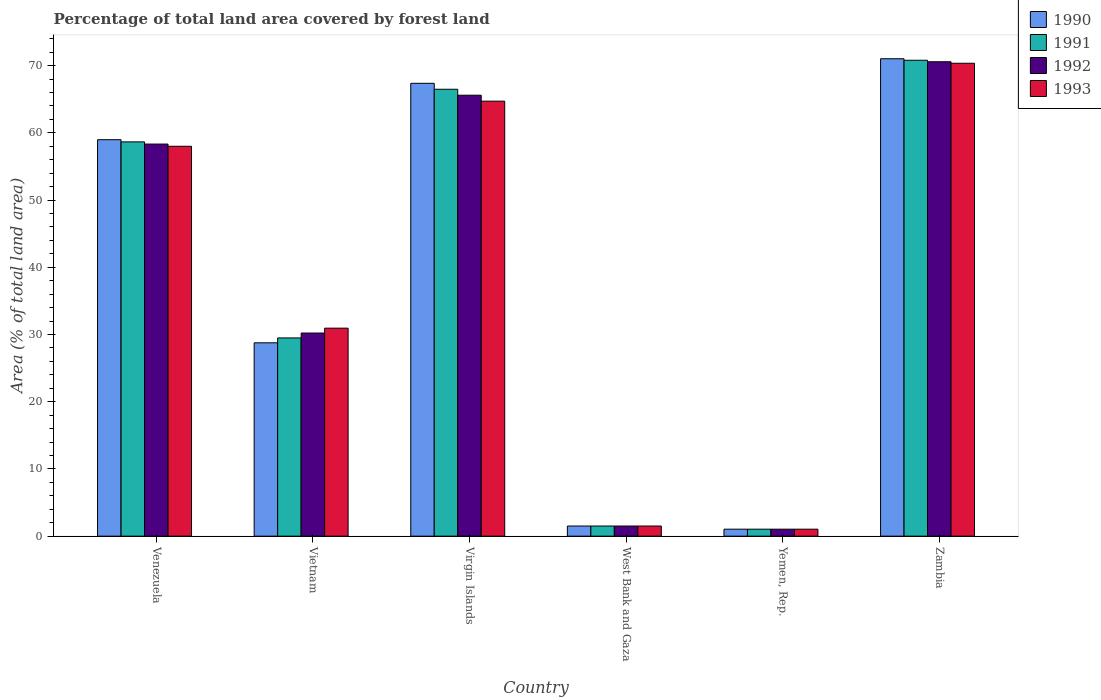How many groups of bars are there?
Your response must be concise. 6. What is the label of the 2nd group of bars from the left?
Offer a very short reply. Vietnam. In how many cases, is the number of bars for a given country not equal to the number of legend labels?
Your response must be concise. 0. What is the percentage of forest land in 1992 in West Bank and Gaza?
Your response must be concise. 1.51. Across all countries, what is the maximum percentage of forest land in 1993?
Provide a succinct answer. 70.35. Across all countries, what is the minimum percentage of forest land in 1991?
Give a very brief answer. 1.04. In which country was the percentage of forest land in 1990 maximum?
Provide a short and direct response. Zambia. In which country was the percentage of forest land in 1991 minimum?
Keep it short and to the point. Yemen, Rep. What is the total percentage of forest land in 1992 in the graph?
Your answer should be very brief. 227.28. What is the difference between the percentage of forest land in 1990 in Vietnam and that in West Bank and Gaza?
Offer a terse response. 27.26. What is the difference between the percentage of forest land in 1990 in Yemen, Rep. and the percentage of forest land in 1992 in Virgin Islands?
Your response must be concise. -64.56. What is the average percentage of forest land in 1992 per country?
Make the answer very short. 37.88. What is the difference between the percentage of forest land of/in 1990 and percentage of forest land of/in 1993 in Virgin Islands?
Your answer should be compact. 2.66. In how many countries, is the percentage of forest land in 1992 greater than 38 %?
Offer a very short reply. 3. What is the ratio of the percentage of forest land in 1991 in West Bank and Gaza to that in Zambia?
Keep it short and to the point. 0.02. Is the difference between the percentage of forest land in 1990 in Vietnam and Zambia greater than the difference between the percentage of forest land in 1993 in Vietnam and Zambia?
Ensure brevity in your answer.  No. What is the difference between the highest and the second highest percentage of forest land in 1992?
Keep it short and to the point. 7.27. What is the difference between the highest and the lowest percentage of forest land in 1992?
Make the answer very short. 69.54. Is the sum of the percentage of forest land in 1993 in Venezuela and West Bank and Gaza greater than the maximum percentage of forest land in 1990 across all countries?
Give a very brief answer. No. What does the 4th bar from the left in West Bank and Gaza represents?
Make the answer very short. 1993. Are all the bars in the graph horizontal?
Ensure brevity in your answer.  No. What is the difference between two consecutive major ticks on the Y-axis?
Give a very brief answer. 10. Does the graph contain any zero values?
Offer a terse response. No. Does the graph contain grids?
Your answer should be compact. No. Where does the legend appear in the graph?
Provide a short and direct response. Top right. How are the legend labels stacked?
Keep it short and to the point. Vertical. What is the title of the graph?
Your answer should be compact. Percentage of total land area covered by forest land. Does "2011" appear as one of the legend labels in the graph?
Ensure brevity in your answer.  No. What is the label or title of the Y-axis?
Your response must be concise. Area (% of total land area). What is the Area (% of total land area) in 1990 in Venezuela?
Provide a succinct answer. 58.98. What is the Area (% of total land area) in 1991 in Venezuela?
Provide a succinct answer. 58.66. What is the Area (% of total land area) in 1992 in Venezuela?
Provide a succinct answer. 58.33. What is the Area (% of total land area) of 1993 in Venezuela?
Provide a succinct answer. 58.01. What is the Area (% of total land area) in 1990 in Vietnam?
Provide a short and direct response. 28.77. What is the Area (% of total land area) of 1991 in Vietnam?
Your answer should be very brief. 29.49. What is the Area (% of total land area) in 1992 in Vietnam?
Provide a short and direct response. 30.22. What is the Area (% of total land area) in 1993 in Vietnam?
Keep it short and to the point. 30.94. What is the Area (% of total land area) of 1990 in Virgin Islands?
Offer a very short reply. 67.37. What is the Area (% of total land area) in 1991 in Virgin Islands?
Your answer should be compact. 66.49. What is the Area (% of total land area) of 1992 in Virgin Islands?
Make the answer very short. 65.6. What is the Area (% of total land area) of 1993 in Virgin Islands?
Offer a terse response. 64.71. What is the Area (% of total land area) of 1990 in West Bank and Gaza?
Keep it short and to the point. 1.51. What is the Area (% of total land area) in 1991 in West Bank and Gaza?
Offer a very short reply. 1.51. What is the Area (% of total land area) of 1992 in West Bank and Gaza?
Offer a terse response. 1.51. What is the Area (% of total land area) in 1993 in West Bank and Gaza?
Your response must be concise. 1.51. What is the Area (% of total land area) of 1990 in Yemen, Rep.?
Ensure brevity in your answer.  1.04. What is the Area (% of total land area) of 1991 in Yemen, Rep.?
Your answer should be compact. 1.04. What is the Area (% of total land area) of 1992 in Yemen, Rep.?
Provide a short and direct response. 1.04. What is the Area (% of total land area) of 1993 in Yemen, Rep.?
Provide a succinct answer. 1.04. What is the Area (% of total land area) of 1990 in Zambia?
Your answer should be very brief. 71.03. What is the Area (% of total land area) of 1991 in Zambia?
Your response must be concise. 70.8. What is the Area (% of total land area) in 1992 in Zambia?
Your answer should be compact. 70.58. What is the Area (% of total land area) of 1993 in Zambia?
Provide a short and direct response. 70.35. Across all countries, what is the maximum Area (% of total land area) of 1990?
Offer a very short reply. 71.03. Across all countries, what is the maximum Area (% of total land area) in 1991?
Give a very brief answer. 70.8. Across all countries, what is the maximum Area (% of total land area) in 1992?
Give a very brief answer. 70.58. Across all countries, what is the maximum Area (% of total land area) of 1993?
Your response must be concise. 70.35. Across all countries, what is the minimum Area (% of total land area) in 1990?
Provide a succinct answer. 1.04. Across all countries, what is the minimum Area (% of total land area) in 1991?
Offer a terse response. 1.04. Across all countries, what is the minimum Area (% of total land area) of 1992?
Your answer should be very brief. 1.04. Across all countries, what is the minimum Area (% of total land area) in 1993?
Offer a terse response. 1.04. What is the total Area (% of total land area) of 1990 in the graph?
Keep it short and to the point. 228.69. What is the total Area (% of total land area) of 1991 in the graph?
Offer a very short reply. 227.99. What is the total Area (% of total land area) in 1992 in the graph?
Ensure brevity in your answer.  227.28. What is the total Area (% of total land area) in 1993 in the graph?
Your response must be concise. 226.57. What is the difference between the Area (% of total land area) in 1990 in Venezuela and that in Vietnam?
Make the answer very short. 30.22. What is the difference between the Area (% of total land area) in 1991 in Venezuela and that in Vietnam?
Your response must be concise. 29.16. What is the difference between the Area (% of total land area) in 1992 in Venezuela and that in Vietnam?
Your answer should be compact. 28.11. What is the difference between the Area (% of total land area) of 1993 in Venezuela and that in Vietnam?
Your answer should be compact. 27.06. What is the difference between the Area (% of total land area) in 1990 in Venezuela and that in Virgin Islands?
Provide a short and direct response. -8.39. What is the difference between the Area (% of total land area) in 1991 in Venezuela and that in Virgin Islands?
Your response must be concise. -7.83. What is the difference between the Area (% of total land area) of 1992 in Venezuela and that in Virgin Islands?
Your answer should be compact. -7.27. What is the difference between the Area (% of total land area) of 1993 in Venezuela and that in Virgin Islands?
Your answer should be very brief. -6.71. What is the difference between the Area (% of total land area) in 1990 in Venezuela and that in West Bank and Gaza?
Offer a very short reply. 57.47. What is the difference between the Area (% of total land area) in 1991 in Venezuela and that in West Bank and Gaza?
Provide a short and direct response. 57.15. What is the difference between the Area (% of total land area) in 1992 in Venezuela and that in West Bank and Gaza?
Offer a terse response. 56.82. What is the difference between the Area (% of total land area) of 1993 in Venezuela and that in West Bank and Gaza?
Keep it short and to the point. 56.5. What is the difference between the Area (% of total land area) in 1990 in Venezuela and that in Yemen, Rep.?
Provide a short and direct response. 57.94. What is the difference between the Area (% of total land area) of 1991 in Venezuela and that in Yemen, Rep.?
Make the answer very short. 57.62. What is the difference between the Area (% of total land area) in 1992 in Venezuela and that in Yemen, Rep.?
Give a very brief answer. 57.29. What is the difference between the Area (% of total land area) of 1993 in Venezuela and that in Yemen, Rep.?
Your response must be concise. 56.97. What is the difference between the Area (% of total land area) of 1990 in Venezuela and that in Zambia?
Your answer should be compact. -12.04. What is the difference between the Area (% of total land area) of 1991 in Venezuela and that in Zambia?
Offer a very short reply. -12.14. What is the difference between the Area (% of total land area) of 1992 in Venezuela and that in Zambia?
Offer a terse response. -12.25. What is the difference between the Area (% of total land area) of 1993 in Venezuela and that in Zambia?
Make the answer very short. -12.35. What is the difference between the Area (% of total land area) of 1990 in Vietnam and that in Virgin Islands?
Keep it short and to the point. -38.61. What is the difference between the Area (% of total land area) in 1991 in Vietnam and that in Virgin Islands?
Make the answer very short. -36.99. What is the difference between the Area (% of total land area) of 1992 in Vietnam and that in Virgin Islands?
Make the answer very short. -35.38. What is the difference between the Area (% of total land area) in 1993 in Vietnam and that in Virgin Islands?
Provide a short and direct response. -33.77. What is the difference between the Area (% of total land area) of 1990 in Vietnam and that in West Bank and Gaza?
Keep it short and to the point. 27.26. What is the difference between the Area (% of total land area) in 1991 in Vietnam and that in West Bank and Gaza?
Make the answer very short. 27.98. What is the difference between the Area (% of total land area) of 1992 in Vietnam and that in West Bank and Gaza?
Your response must be concise. 28.71. What is the difference between the Area (% of total land area) in 1993 in Vietnam and that in West Bank and Gaza?
Make the answer very short. 29.44. What is the difference between the Area (% of total land area) of 1990 in Vietnam and that in Yemen, Rep.?
Your answer should be compact. 27.73. What is the difference between the Area (% of total land area) in 1991 in Vietnam and that in Yemen, Rep.?
Your answer should be very brief. 28.45. What is the difference between the Area (% of total land area) in 1992 in Vietnam and that in Yemen, Rep.?
Your answer should be compact. 29.18. What is the difference between the Area (% of total land area) in 1993 in Vietnam and that in Yemen, Rep.?
Your answer should be very brief. 29.9. What is the difference between the Area (% of total land area) of 1990 in Vietnam and that in Zambia?
Your response must be concise. -42.26. What is the difference between the Area (% of total land area) in 1991 in Vietnam and that in Zambia?
Make the answer very short. -41.31. What is the difference between the Area (% of total land area) in 1992 in Vietnam and that in Zambia?
Make the answer very short. -40.36. What is the difference between the Area (% of total land area) in 1993 in Vietnam and that in Zambia?
Offer a very short reply. -39.41. What is the difference between the Area (% of total land area) of 1990 in Virgin Islands and that in West Bank and Gaza?
Offer a terse response. 65.86. What is the difference between the Area (% of total land area) of 1991 in Virgin Islands and that in West Bank and Gaza?
Provide a succinct answer. 64.98. What is the difference between the Area (% of total land area) of 1992 in Virgin Islands and that in West Bank and Gaza?
Keep it short and to the point. 64.09. What is the difference between the Area (% of total land area) in 1993 in Virgin Islands and that in West Bank and Gaza?
Offer a terse response. 63.21. What is the difference between the Area (% of total land area) of 1990 in Virgin Islands and that in Yemen, Rep.?
Give a very brief answer. 66.33. What is the difference between the Area (% of total land area) of 1991 in Virgin Islands and that in Yemen, Rep.?
Your answer should be very brief. 65.45. What is the difference between the Area (% of total land area) of 1992 in Virgin Islands and that in Yemen, Rep.?
Offer a terse response. 64.56. What is the difference between the Area (% of total land area) in 1993 in Virgin Islands and that in Yemen, Rep.?
Offer a terse response. 63.67. What is the difference between the Area (% of total land area) in 1990 in Virgin Islands and that in Zambia?
Keep it short and to the point. -3.65. What is the difference between the Area (% of total land area) in 1991 in Virgin Islands and that in Zambia?
Keep it short and to the point. -4.32. What is the difference between the Area (% of total land area) in 1992 in Virgin Islands and that in Zambia?
Your answer should be very brief. -4.98. What is the difference between the Area (% of total land area) in 1993 in Virgin Islands and that in Zambia?
Your answer should be compact. -5.64. What is the difference between the Area (% of total land area) in 1990 in West Bank and Gaza and that in Yemen, Rep.?
Provide a short and direct response. 0.47. What is the difference between the Area (% of total land area) of 1991 in West Bank and Gaza and that in Yemen, Rep.?
Offer a very short reply. 0.47. What is the difference between the Area (% of total land area) of 1992 in West Bank and Gaza and that in Yemen, Rep.?
Your answer should be compact. 0.47. What is the difference between the Area (% of total land area) of 1993 in West Bank and Gaza and that in Yemen, Rep.?
Your response must be concise. 0.47. What is the difference between the Area (% of total land area) in 1990 in West Bank and Gaza and that in Zambia?
Keep it short and to the point. -69.52. What is the difference between the Area (% of total land area) of 1991 in West Bank and Gaza and that in Zambia?
Your answer should be compact. -69.29. What is the difference between the Area (% of total land area) of 1992 in West Bank and Gaza and that in Zambia?
Your answer should be compact. -69.07. What is the difference between the Area (% of total land area) in 1993 in West Bank and Gaza and that in Zambia?
Your answer should be very brief. -68.85. What is the difference between the Area (% of total land area) of 1990 in Yemen, Rep. and that in Zambia?
Offer a very short reply. -69.99. What is the difference between the Area (% of total land area) in 1991 in Yemen, Rep. and that in Zambia?
Your response must be concise. -69.76. What is the difference between the Area (% of total land area) of 1992 in Yemen, Rep. and that in Zambia?
Offer a terse response. -69.54. What is the difference between the Area (% of total land area) of 1993 in Yemen, Rep. and that in Zambia?
Give a very brief answer. -69.31. What is the difference between the Area (% of total land area) in 1990 in Venezuela and the Area (% of total land area) in 1991 in Vietnam?
Ensure brevity in your answer.  29.49. What is the difference between the Area (% of total land area) of 1990 in Venezuela and the Area (% of total land area) of 1992 in Vietnam?
Give a very brief answer. 28.76. What is the difference between the Area (% of total land area) in 1990 in Venezuela and the Area (% of total land area) in 1993 in Vietnam?
Provide a short and direct response. 28.04. What is the difference between the Area (% of total land area) of 1991 in Venezuela and the Area (% of total land area) of 1992 in Vietnam?
Give a very brief answer. 28.44. What is the difference between the Area (% of total land area) of 1991 in Venezuela and the Area (% of total land area) of 1993 in Vietnam?
Provide a short and direct response. 27.71. What is the difference between the Area (% of total land area) of 1992 in Venezuela and the Area (% of total land area) of 1993 in Vietnam?
Your answer should be compact. 27.39. What is the difference between the Area (% of total land area) of 1990 in Venezuela and the Area (% of total land area) of 1991 in Virgin Islands?
Your answer should be very brief. -7.5. What is the difference between the Area (% of total land area) of 1990 in Venezuela and the Area (% of total land area) of 1992 in Virgin Islands?
Make the answer very short. -6.62. What is the difference between the Area (% of total land area) of 1990 in Venezuela and the Area (% of total land area) of 1993 in Virgin Islands?
Provide a short and direct response. -5.73. What is the difference between the Area (% of total land area) of 1991 in Venezuela and the Area (% of total land area) of 1992 in Virgin Islands?
Offer a very short reply. -6.94. What is the difference between the Area (% of total land area) in 1991 in Venezuela and the Area (% of total land area) in 1993 in Virgin Islands?
Offer a very short reply. -6.06. What is the difference between the Area (% of total land area) of 1992 in Venezuela and the Area (% of total land area) of 1993 in Virgin Islands?
Offer a very short reply. -6.38. What is the difference between the Area (% of total land area) of 1990 in Venezuela and the Area (% of total land area) of 1991 in West Bank and Gaza?
Provide a succinct answer. 57.47. What is the difference between the Area (% of total land area) in 1990 in Venezuela and the Area (% of total land area) in 1992 in West Bank and Gaza?
Keep it short and to the point. 57.47. What is the difference between the Area (% of total land area) of 1990 in Venezuela and the Area (% of total land area) of 1993 in West Bank and Gaza?
Provide a succinct answer. 57.47. What is the difference between the Area (% of total land area) of 1991 in Venezuela and the Area (% of total land area) of 1992 in West Bank and Gaza?
Offer a very short reply. 57.15. What is the difference between the Area (% of total land area) in 1991 in Venezuela and the Area (% of total land area) in 1993 in West Bank and Gaza?
Offer a terse response. 57.15. What is the difference between the Area (% of total land area) of 1992 in Venezuela and the Area (% of total land area) of 1993 in West Bank and Gaza?
Your response must be concise. 56.82. What is the difference between the Area (% of total land area) of 1990 in Venezuela and the Area (% of total land area) of 1991 in Yemen, Rep.?
Provide a short and direct response. 57.94. What is the difference between the Area (% of total land area) in 1990 in Venezuela and the Area (% of total land area) in 1992 in Yemen, Rep.?
Your answer should be very brief. 57.94. What is the difference between the Area (% of total land area) of 1990 in Venezuela and the Area (% of total land area) of 1993 in Yemen, Rep.?
Provide a succinct answer. 57.94. What is the difference between the Area (% of total land area) in 1991 in Venezuela and the Area (% of total land area) in 1992 in Yemen, Rep.?
Make the answer very short. 57.62. What is the difference between the Area (% of total land area) of 1991 in Venezuela and the Area (% of total land area) of 1993 in Yemen, Rep.?
Make the answer very short. 57.62. What is the difference between the Area (% of total land area) in 1992 in Venezuela and the Area (% of total land area) in 1993 in Yemen, Rep.?
Provide a short and direct response. 57.29. What is the difference between the Area (% of total land area) of 1990 in Venezuela and the Area (% of total land area) of 1991 in Zambia?
Provide a succinct answer. -11.82. What is the difference between the Area (% of total land area) of 1990 in Venezuela and the Area (% of total land area) of 1992 in Zambia?
Offer a terse response. -11.59. What is the difference between the Area (% of total land area) in 1990 in Venezuela and the Area (% of total land area) in 1993 in Zambia?
Make the answer very short. -11.37. What is the difference between the Area (% of total land area) of 1991 in Venezuela and the Area (% of total land area) of 1992 in Zambia?
Offer a terse response. -11.92. What is the difference between the Area (% of total land area) in 1991 in Venezuela and the Area (% of total land area) in 1993 in Zambia?
Keep it short and to the point. -11.7. What is the difference between the Area (% of total land area) in 1992 in Venezuela and the Area (% of total land area) in 1993 in Zambia?
Offer a terse response. -12.02. What is the difference between the Area (% of total land area) of 1990 in Vietnam and the Area (% of total land area) of 1991 in Virgin Islands?
Your answer should be very brief. -37.72. What is the difference between the Area (% of total land area) of 1990 in Vietnam and the Area (% of total land area) of 1992 in Virgin Islands?
Make the answer very short. -36.83. What is the difference between the Area (% of total land area) in 1990 in Vietnam and the Area (% of total land area) in 1993 in Virgin Islands?
Make the answer very short. -35.95. What is the difference between the Area (% of total land area) in 1991 in Vietnam and the Area (% of total land area) in 1992 in Virgin Islands?
Your answer should be compact. -36.11. What is the difference between the Area (% of total land area) of 1991 in Vietnam and the Area (% of total land area) of 1993 in Virgin Islands?
Provide a short and direct response. -35.22. What is the difference between the Area (% of total land area) of 1992 in Vietnam and the Area (% of total land area) of 1993 in Virgin Islands?
Your answer should be compact. -34.5. What is the difference between the Area (% of total land area) in 1990 in Vietnam and the Area (% of total land area) in 1991 in West Bank and Gaza?
Provide a short and direct response. 27.26. What is the difference between the Area (% of total land area) in 1990 in Vietnam and the Area (% of total land area) in 1992 in West Bank and Gaza?
Provide a succinct answer. 27.26. What is the difference between the Area (% of total land area) of 1990 in Vietnam and the Area (% of total land area) of 1993 in West Bank and Gaza?
Provide a short and direct response. 27.26. What is the difference between the Area (% of total land area) of 1991 in Vietnam and the Area (% of total land area) of 1992 in West Bank and Gaza?
Provide a succinct answer. 27.98. What is the difference between the Area (% of total land area) in 1991 in Vietnam and the Area (% of total land area) in 1993 in West Bank and Gaza?
Your answer should be very brief. 27.98. What is the difference between the Area (% of total land area) in 1992 in Vietnam and the Area (% of total land area) in 1993 in West Bank and Gaza?
Your answer should be compact. 28.71. What is the difference between the Area (% of total land area) in 1990 in Vietnam and the Area (% of total land area) in 1991 in Yemen, Rep.?
Offer a very short reply. 27.73. What is the difference between the Area (% of total land area) of 1990 in Vietnam and the Area (% of total land area) of 1992 in Yemen, Rep.?
Provide a short and direct response. 27.73. What is the difference between the Area (% of total land area) of 1990 in Vietnam and the Area (% of total land area) of 1993 in Yemen, Rep.?
Your response must be concise. 27.73. What is the difference between the Area (% of total land area) of 1991 in Vietnam and the Area (% of total land area) of 1992 in Yemen, Rep.?
Make the answer very short. 28.45. What is the difference between the Area (% of total land area) of 1991 in Vietnam and the Area (% of total land area) of 1993 in Yemen, Rep.?
Ensure brevity in your answer.  28.45. What is the difference between the Area (% of total land area) of 1992 in Vietnam and the Area (% of total land area) of 1993 in Yemen, Rep.?
Your answer should be compact. 29.18. What is the difference between the Area (% of total land area) in 1990 in Vietnam and the Area (% of total land area) in 1991 in Zambia?
Ensure brevity in your answer.  -42.04. What is the difference between the Area (% of total land area) in 1990 in Vietnam and the Area (% of total land area) in 1992 in Zambia?
Your answer should be compact. -41.81. What is the difference between the Area (% of total land area) of 1990 in Vietnam and the Area (% of total land area) of 1993 in Zambia?
Your answer should be very brief. -41.59. What is the difference between the Area (% of total land area) of 1991 in Vietnam and the Area (% of total land area) of 1992 in Zambia?
Offer a very short reply. -41.09. What is the difference between the Area (% of total land area) in 1991 in Vietnam and the Area (% of total land area) in 1993 in Zambia?
Give a very brief answer. -40.86. What is the difference between the Area (% of total land area) of 1992 in Vietnam and the Area (% of total land area) of 1993 in Zambia?
Make the answer very short. -40.14. What is the difference between the Area (% of total land area) in 1990 in Virgin Islands and the Area (% of total land area) in 1991 in West Bank and Gaza?
Make the answer very short. 65.86. What is the difference between the Area (% of total land area) in 1990 in Virgin Islands and the Area (% of total land area) in 1992 in West Bank and Gaza?
Offer a terse response. 65.86. What is the difference between the Area (% of total land area) in 1990 in Virgin Islands and the Area (% of total land area) in 1993 in West Bank and Gaza?
Your answer should be compact. 65.86. What is the difference between the Area (% of total land area) of 1991 in Virgin Islands and the Area (% of total land area) of 1992 in West Bank and Gaza?
Your response must be concise. 64.98. What is the difference between the Area (% of total land area) of 1991 in Virgin Islands and the Area (% of total land area) of 1993 in West Bank and Gaza?
Provide a short and direct response. 64.98. What is the difference between the Area (% of total land area) in 1992 in Virgin Islands and the Area (% of total land area) in 1993 in West Bank and Gaza?
Ensure brevity in your answer.  64.09. What is the difference between the Area (% of total land area) in 1990 in Virgin Islands and the Area (% of total land area) in 1991 in Yemen, Rep.?
Your response must be concise. 66.33. What is the difference between the Area (% of total land area) in 1990 in Virgin Islands and the Area (% of total land area) in 1992 in Yemen, Rep.?
Your answer should be very brief. 66.33. What is the difference between the Area (% of total land area) of 1990 in Virgin Islands and the Area (% of total land area) of 1993 in Yemen, Rep.?
Your response must be concise. 66.33. What is the difference between the Area (% of total land area) in 1991 in Virgin Islands and the Area (% of total land area) in 1992 in Yemen, Rep.?
Ensure brevity in your answer.  65.45. What is the difference between the Area (% of total land area) in 1991 in Virgin Islands and the Area (% of total land area) in 1993 in Yemen, Rep.?
Provide a short and direct response. 65.45. What is the difference between the Area (% of total land area) of 1992 in Virgin Islands and the Area (% of total land area) of 1993 in Yemen, Rep.?
Make the answer very short. 64.56. What is the difference between the Area (% of total land area) of 1990 in Virgin Islands and the Area (% of total land area) of 1991 in Zambia?
Your answer should be very brief. -3.43. What is the difference between the Area (% of total land area) in 1990 in Virgin Islands and the Area (% of total land area) in 1992 in Zambia?
Provide a short and direct response. -3.21. What is the difference between the Area (% of total land area) in 1990 in Virgin Islands and the Area (% of total land area) in 1993 in Zambia?
Keep it short and to the point. -2.98. What is the difference between the Area (% of total land area) in 1991 in Virgin Islands and the Area (% of total land area) in 1992 in Zambia?
Make the answer very short. -4.09. What is the difference between the Area (% of total land area) in 1991 in Virgin Islands and the Area (% of total land area) in 1993 in Zambia?
Give a very brief answer. -3.87. What is the difference between the Area (% of total land area) in 1992 in Virgin Islands and the Area (% of total land area) in 1993 in Zambia?
Your response must be concise. -4.75. What is the difference between the Area (% of total land area) in 1990 in West Bank and Gaza and the Area (% of total land area) in 1991 in Yemen, Rep.?
Ensure brevity in your answer.  0.47. What is the difference between the Area (% of total land area) of 1990 in West Bank and Gaza and the Area (% of total land area) of 1992 in Yemen, Rep.?
Give a very brief answer. 0.47. What is the difference between the Area (% of total land area) of 1990 in West Bank and Gaza and the Area (% of total land area) of 1993 in Yemen, Rep.?
Your answer should be compact. 0.47. What is the difference between the Area (% of total land area) in 1991 in West Bank and Gaza and the Area (% of total land area) in 1992 in Yemen, Rep.?
Offer a very short reply. 0.47. What is the difference between the Area (% of total land area) in 1991 in West Bank and Gaza and the Area (% of total land area) in 1993 in Yemen, Rep.?
Give a very brief answer. 0.47. What is the difference between the Area (% of total land area) of 1992 in West Bank and Gaza and the Area (% of total land area) of 1993 in Yemen, Rep.?
Give a very brief answer. 0.47. What is the difference between the Area (% of total land area) in 1990 in West Bank and Gaza and the Area (% of total land area) in 1991 in Zambia?
Make the answer very short. -69.29. What is the difference between the Area (% of total land area) of 1990 in West Bank and Gaza and the Area (% of total land area) of 1992 in Zambia?
Make the answer very short. -69.07. What is the difference between the Area (% of total land area) of 1990 in West Bank and Gaza and the Area (% of total land area) of 1993 in Zambia?
Make the answer very short. -68.85. What is the difference between the Area (% of total land area) in 1991 in West Bank and Gaza and the Area (% of total land area) in 1992 in Zambia?
Provide a succinct answer. -69.07. What is the difference between the Area (% of total land area) of 1991 in West Bank and Gaza and the Area (% of total land area) of 1993 in Zambia?
Keep it short and to the point. -68.85. What is the difference between the Area (% of total land area) of 1992 in West Bank and Gaza and the Area (% of total land area) of 1993 in Zambia?
Ensure brevity in your answer.  -68.85. What is the difference between the Area (% of total land area) in 1990 in Yemen, Rep. and the Area (% of total land area) in 1991 in Zambia?
Provide a short and direct response. -69.76. What is the difference between the Area (% of total land area) in 1990 in Yemen, Rep. and the Area (% of total land area) in 1992 in Zambia?
Make the answer very short. -69.54. What is the difference between the Area (% of total land area) in 1990 in Yemen, Rep. and the Area (% of total land area) in 1993 in Zambia?
Your answer should be compact. -69.31. What is the difference between the Area (% of total land area) in 1991 in Yemen, Rep. and the Area (% of total land area) in 1992 in Zambia?
Ensure brevity in your answer.  -69.54. What is the difference between the Area (% of total land area) in 1991 in Yemen, Rep. and the Area (% of total land area) in 1993 in Zambia?
Make the answer very short. -69.31. What is the difference between the Area (% of total land area) in 1992 in Yemen, Rep. and the Area (% of total land area) in 1993 in Zambia?
Your response must be concise. -69.31. What is the average Area (% of total land area) of 1990 per country?
Give a very brief answer. 38.12. What is the average Area (% of total land area) of 1991 per country?
Provide a succinct answer. 38. What is the average Area (% of total land area) in 1992 per country?
Provide a short and direct response. 37.88. What is the average Area (% of total land area) of 1993 per country?
Your answer should be compact. 37.76. What is the difference between the Area (% of total land area) of 1990 and Area (% of total land area) of 1991 in Venezuela?
Give a very brief answer. 0.33. What is the difference between the Area (% of total land area) in 1990 and Area (% of total land area) in 1992 in Venezuela?
Your answer should be compact. 0.65. What is the difference between the Area (% of total land area) of 1990 and Area (% of total land area) of 1993 in Venezuela?
Provide a succinct answer. 0.98. What is the difference between the Area (% of total land area) in 1991 and Area (% of total land area) in 1992 in Venezuela?
Give a very brief answer. 0.33. What is the difference between the Area (% of total land area) of 1991 and Area (% of total land area) of 1993 in Venezuela?
Your answer should be compact. 0.65. What is the difference between the Area (% of total land area) in 1992 and Area (% of total land area) in 1993 in Venezuela?
Ensure brevity in your answer.  0.33. What is the difference between the Area (% of total land area) of 1990 and Area (% of total land area) of 1991 in Vietnam?
Keep it short and to the point. -0.73. What is the difference between the Area (% of total land area) in 1990 and Area (% of total land area) in 1992 in Vietnam?
Give a very brief answer. -1.45. What is the difference between the Area (% of total land area) of 1990 and Area (% of total land area) of 1993 in Vietnam?
Ensure brevity in your answer.  -2.18. What is the difference between the Area (% of total land area) in 1991 and Area (% of total land area) in 1992 in Vietnam?
Your answer should be compact. -0.73. What is the difference between the Area (% of total land area) of 1991 and Area (% of total land area) of 1993 in Vietnam?
Provide a short and direct response. -1.45. What is the difference between the Area (% of total land area) of 1992 and Area (% of total land area) of 1993 in Vietnam?
Offer a very short reply. -0.73. What is the difference between the Area (% of total land area) in 1990 and Area (% of total land area) in 1991 in Virgin Islands?
Provide a succinct answer. 0.89. What is the difference between the Area (% of total land area) in 1990 and Area (% of total land area) in 1992 in Virgin Islands?
Offer a terse response. 1.77. What is the difference between the Area (% of total land area) of 1990 and Area (% of total land area) of 1993 in Virgin Islands?
Your answer should be compact. 2.66. What is the difference between the Area (% of total land area) of 1991 and Area (% of total land area) of 1992 in Virgin Islands?
Provide a short and direct response. 0.89. What is the difference between the Area (% of total land area) in 1991 and Area (% of total land area) in 1993 in Virgin Islands?
Your answer should be very brief. 1.77. What is the difference between the Area (% of total land area) in 1992 and Area (% of total land area) in 1993 in Virgin Islands?
Your answer should be very brief. 0.89. What is the difference between the Area (% of total land area) in 1990 and Area (% of total land area) in 1991 in West Bank and Gaza?
Keep it short and to the point. 0. What is the difference between the Area (% of total land area) in 1991 and Area (% of total land area) in 1993 in West Bank and Gaza?
Make the answer very short. 0. What is the difference between the Area (% of total land area) in 1992 and Area (% of total land area) in 1993 in West Bank and Gaza?
Make the answer very short. 0. What is the difference between the Area (% of total land area) of 1990 and Area (% of total land area) of 1991 in Yemen, Rep.?
Provide a short and direct response. 0. What is the difference between the Area (% of total land area) of 1990 and Area (% of total land area) of 1993 in Yemen, Rep.?
Your answer should be compact. 0. What is the difference between the Area (% of total land area) of 1991 and Area (% of total land area) of 1992 in Yemen, Rep.?
Make the answer very short. 0. What is the difference between the Area (% of total land area) in 1990 and Area (% of total land area) in 1991 in Zambia?
Your answer should be very brief. 0.22. What is the difference between the Area (% of total land area) of 1990 and Area (% of total land area) of 1992 in Zambia?
Offer a terse response. 0.45. What is the difference between the Area (% of total land area) in 1990 and Area (% of total land area) in 1993 in Zambia?
Keep it short and to the point. 0.67. What is the difference between the Area (% of total land area) in 1991 and Area (% of total land area) in 1992 in Zambia?
Your response must be concise. 0.22. What is the difference between the Area (% of total land area) of 1991 and Area (% of total land area) of 1993 in Zambia?
Make the answer very short. 0.45. What is the difference between the Area (% of total land area) in 1992 and Area (% of total land area) in 1993 in Zambia?
Give a very brief answer. 0.22. What is the ratio of the Area (% of total land area) of 1990 in Venezuela to that in Vietnam?
Provide a short and direct response. 2.05. What is the ratio of the Area (% of total land area) of 1991 in Venezuela to that in Vietnam?
Ensure brevity in your answer.  1.99. What is the ratio of the Area (% of total land area) of 1992 in Venezuela to that in Vietnam?
Your response must be concise. 1.93. What is the ratio of the Area (% of total land area) of 1993 in Venezuela to that in Vietnam?
Provide a short and direct response. 1.87. What is the ratio of the Area (% of total land area) in 1990 in Venezuela to that in Virgin Islands?
Give a very brief answer. 0.88. What is the ratio of the Area (% of total land area) of 1991 in Venezuela to that in Virgin Islands?
Your response must be concise. 0.88. What is the ratio of the Area (% of total land area) of 1992 in Venezuela to that in Virgin Islands?
Provide a short and direct response. 0.89. What is the ratio of the Area (% of total land area) of 1993 in Venezuela to that in Virgin Islands?
Make the answer very short. 0.9. What is the ratio of the Area (% of total land area) of 1990 in Venezuela to that in West Bank and Gaza?
Offer a terse response. 39.11. What is the ratio of the Area (% of total land area) of 1991 in Venezuela to that in West Bank and Gaza?
Make the answer very short. 38.89. What is the ratio of the Area (% of total land area) of 1992 in Venezuela to that in West Bank and Gaza?
Give a very brief answer. 38.67. What is the ratio of the Area (% of total land area) in 1993 in Venezuela to that in West Bank and Gaza?
Make the answer very short. 38.46. What is the ratio of the Area (% of total land area) in 1990 in Venezuela to that in Yemen, Rep.?
Your response must be concise. 56.72. What is the ratio of the Area (% of total land area) in 1991 in Venezuela to that in Yemen, Rep.?
Your answer should be compact. 56.41. What is the ratio of the Area (% of total land area) of 1992 in Venezuela to that in Yemen, Rep.?
Provide a short and direct response. 56.1. What is the ratio of the Area (% of total land area) of 1993 in Venezuela to that in Yemen, Rep.?
Give a very brief answer. 55.78. What is the ratio of the Area (% of total land area) in 1990 in Venezuela to that in Zambia?
Make the answer very short. 0.83. What is the ratio of the Area (% of total land area) of 1991 in Venezuela to that in Zambia?
Offer a very short reply. 0.83. What is the ratio of the Area (% of total land area) of 1992 in Venezuela to that in Zambia?
Provide a short and direct response. 0.83. What is the ratio of the Area (% of total land area) of 1993 in Venezuela to that in Zambia?
Keep it short and to the point. 0.82. What is the ratio of the Area (% of total land area) in 1990 in Vietnam to that in Virgin Islands?
Your answer should be very brief. 0.43. What is the ratio of the Area (% of total land area) of 1991 in Vietnam to that in Virgin Islands?
Keep it short and to the point. 0.44. What is the ratio of the Area (% of total land area) in 1992 in Vietnam to that in Virgin Islands?
Offer a very short reply. 0.46. What is the ratio of the Area (% of total land area) in 1993 in Vietnam to that in Virgin Islands?
Give a very brief answer. 0.48. What is the ratio of the Area (% of total land area) of 1990 in Vietnam to that in West Bank and Gaza?
Keep it short and to the point. 19.07. What is the ratio of the Area (% of total land area) of 1991 in Vietnam to that in West Bank and Gaza?
Your answer should be compact. 19.55. What is the ratio of the Area (% of total land area) of 1992 in Vietnam to that in West Bank and Gaza?
Make the answer very short. 20.03. What is the ratio of the Area (% of total land area) of 1993 in Vietnam to that in West Bank and Gaza?
Your answer should be very brief. 20.52. What is the ratio of the Area (% of total land area) of 1990 in Vietnam to that in Yemen, Rep.?
Make the answer very short. 27.66. What is the ratio of the Area (% of total land area) of 1991 in Vietnam to that in Yemen, Rep.?
Ensure brevity in your answer.  28.36. What is the ratio of the Area (% of total land area) of 1992 in Vietnam to that in Yemen, Rep.?
Your response must be concise. 29.06. What is the ratio of the Area (% of total land area) of 1993 in Vietnam to that in Yemen, Rep.?
Make the answer very short. 29.76. What is the ratio of the Area (% of total land area) in 1990 in Vietnam to that in Zambia?
Give a very brief answer. 0.41. What is the ratio of the Area (% of total land area) in 1991 in Vietnam to that in Zambia?
Your answer should be very brief. 0.42. What is the ratio of the Area (% of total land area) in 1992 in Vietnam to that in Zambia?
Your answer should be compact. 0.43. What is the ratio of the Area (% of total land area) in 1993 in Vietnam to that in Zambia?
Ensure brevity in your answer.  0.44. What is the ratio of the Area (% of total land area) in 1990 in Virgin Islands to that in West Bank and Gaza?
Your response must be concise. 44.67. What is the ratio of the Area (% of total land area) of 1991 in Virgin Islands to that in West Bank and Gaza?
Offer a very short reply. 44.08. What is the ratio of the Area (% of total land area) of 1992 in Virgin Islands to that in West Bank and Gaza?
Your answer should be compact. 43.49. What is the ratio of the Area (% of total land area) in 1993 in Virgin Islands to that in West Bank and Gaza?
Your response must be concise. 42.91. What is the ratio of the Area (% of total land area) of 1990 in Virgin Islands to that in Yemen, Rep.?
Ensure brevity in your answer.  64.79. What is the ratio of the Area (% of total land area) in 1991 in Virgin Islands to that in Yemen, Rep.?
Keep it short and to the point. 63.94. What is the ratio of the Area (% of total land area) in 1992 in Virgin Islands to that in Yemen, Rep.?
Your answer should be compact. 63.09. What is the ratio of the Area (% of total land area) in 1993 in Virgin Islands to that in Yemen, Rep.?
Offer a terse response. 62.24. What is the ratio of the Area (% of total land area) in 1990 in Virgin Islands to that in Zambia?
Offer a terse response. 0.95. What is the ratio of the Area (% of total land area) in 1991 in Virgin Islands to that in Zambia?
Offer a very short reply. 0.94. What is the ratio of the Area (% of total land area) of 1992 in Virgin Islands to that in Zambia?
Provide a succinct answer. 0.93. What is the ratio of the Area (% of total land area) of 1993 in Virgin Islands to that in Zambia?
Make the answer very short. 0.92. What is the ratio of the Area (% of total land area) of 1990 in West Bank and Gaza to that in Yemen, Rep.?
Your answer should be compact. 1.45. What is the ratio of the Area (% of total land area) of 1991 in West Bank and Gaza to that in Yemen, Rep.?
Provide a succinct answer. 1.45. What is the ratio of the Area (% of total land area) in 1992 in West Bank and Gaza to that in Yemen, Rep.?
Your answer should be compact. 1.45. What is the ratio of the Area (% of total land area) of 1993 in West Bank and Gaza to that in Yemen, Rep.?
Keep it short and to the point. 1.45. What is the ratio of the Area (% of total land area) of 1990 in West Bank and Gaza to that in Zambia?
Give a very brief answer. 0.02. What is the ratio of the Area (% of total land area) of 1991 in West Bank and Gaza to that in Zambia?
Ensure brevity in your answer.  0.02. What is the ratio of the Area (% of total land area) of 1992 in West Bank and Gaza to that in Zambia?
Ensure brevity in your answer.  0.02. What is the ratio of the Area (% of total land area) in 1993 in West Bank and Gaza to that in Zambia?
Offer a terse response. 0.02. What is the ratio of the Area (% of total land area) in 1990 in Yemen, Rep. to that in Zambia?
Keep it short and to the point. 0.01. What is the ratio of the Area (% of total land area) in 1991 in Yemen, Rep. to that in Zambia?
Offer a very short reply. 0.01. What is the ratio of the Area (% of total land area) of 1992 in Yemen, Rep. to that in Zambia?
Ensure brevity in your answer.  0.01. What is the ratio of the Area (% of total land area) of 1993 in Yemen, Rep. to that in Zambia?
Provide a succinct answer. 0.01. What is the difference between the highest and the second highest Area (% of total land area) of 1990?
Offer a very short reply. 3.65. What is the difference between the highest and the second highest Area (% of total land area) of 1991?
Your answer should be compact. 4.32. What is the difference between the highest and the second highest Area (% of total land area) in 1992?
Ensure brevity in your answer.  4.98. What is the difference between the highest and the second highest Area (% of total land area) of 1993?
Your answer should be compact. 5.64. What is the difference between the highest and the lowest Area (% of total land area) in 1990?
Your answer should be compact. 69.99. What is the difference between the highest and the lowest Area (% of total land area) in 1991?
Provide a succinct answer. 69.76. What is the difference between the highest and the lowest Area (% of total land area) in 1992?
Give a very brief answer. 69.54. What is the difference between the highest and the lowest Area (% of total land area) of 1993?
Offer a very short reply. 69.31. 